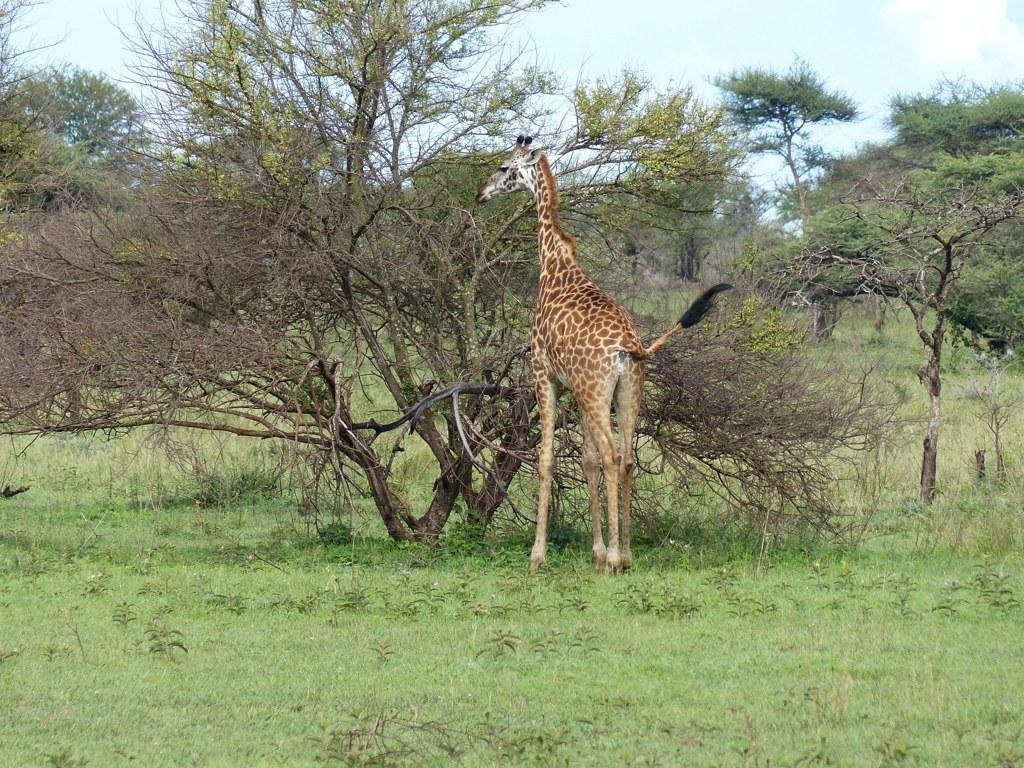What is the main subject in the center of the image? There is a giraffe in the center of the image. What can be seen in the background of the image? There are trees in the background of the image. What type of surface is visible at the bottom of the image? There is ground visible at the bottom of the image. What type of destruction can be seen in the image? There is no destruction present in the image; it features a giraffe, trees, and ground. What type of treatment is being administered to the giraffe in the image? There is no treatment being administered to the giraffe in the image; it is simply standing in the center of the image. 